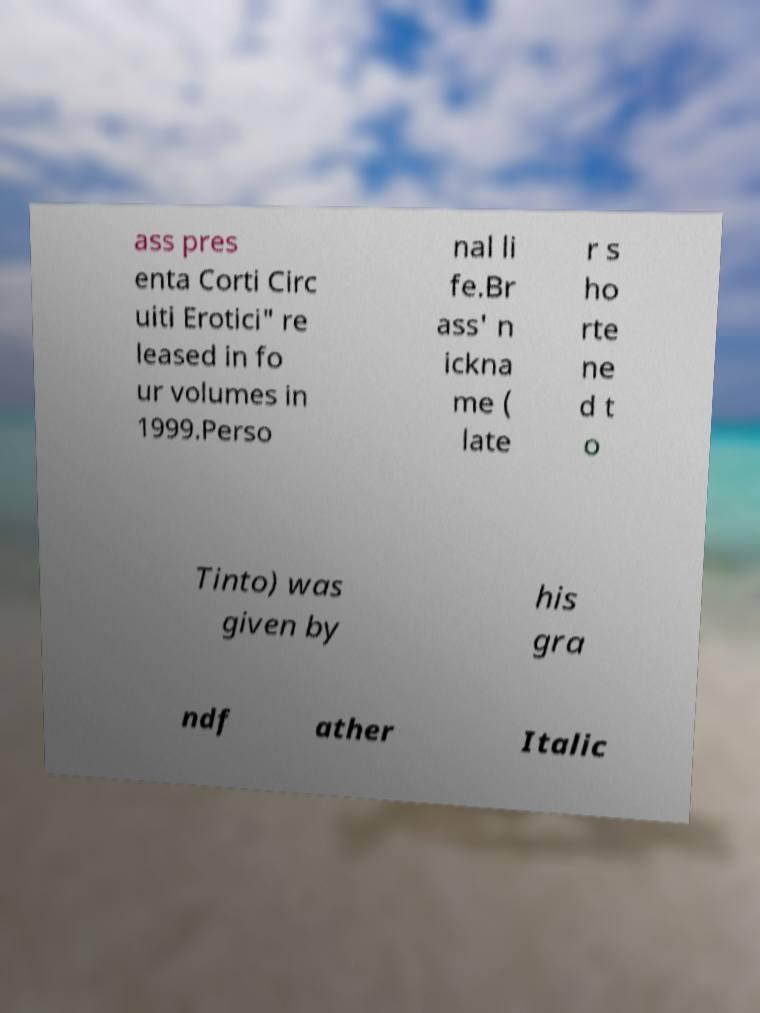I need the written content from this picture converted into text. Can you do that? ass pres enta Corti Circ uiti Erotici" re leased in fo ur volumes in 1999.Perso nal li fe.Br ass' n ickna me ( late r s ho rte ne d t o Tinto) was given by his gra ndf ather Italic 